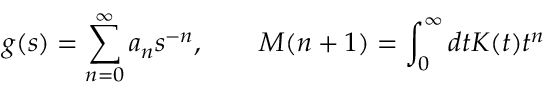Convert formula to latex. <formula><loc_0><loc_0><loc_500><loc_500>g ( s ) = \sum _ { n = 0 } ^ { \infty } a _ { n } s ^ { - n } , \quad M ( n + 1 ) = \int _ { 0 } ^ { \infty } d t K ( t ) t ^ { n }</formula> 